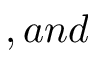<formula> <loc_0><loc_0><loc_500><loc_500>, a n d</formula> 